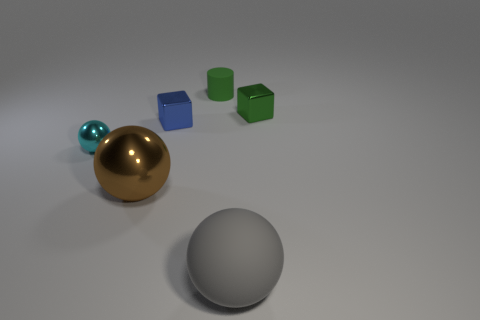Do the green metal block and the brown thing have the same size?
Offer a terse response. No. How big is the metallic ball that is in front of the tiny thing that is on the left side of the metallic thing that is in front of the small cyan metal ball?
Your answer should be very brief. Large. The small rubber object has what shape?
Your answer should be very brief. Cylinder. Are the big sphere to the left of the matte cylinder and the large gray sphere made of the same material?
Provide a succinct answer. No. There is a rubber object behind the metal ball that is to the left of the big brown metal ball; how big is it?
Give a very brief answer. Small. There is a shiny thing that is to the right of the big metallic sphere and to the left of the green metallic object; what is its color?
Offer a terse response. Blue. There is a cylinder that is the same size as the cyan ball; what is its material?
Keep it short and to the point. Rubber. How many other objects are the same material as the small cylinder?
Make the answer very short. 1. There is a metal cube that is on the right side of the green matte cylinder; is it the same color as the rubber object that is behind the big metal object?
Provide a short and direct response. Yes. There is a green object in front of the rubber thing that is behind the cyan object; what shape is it?
Offer a terse response. Cube. 